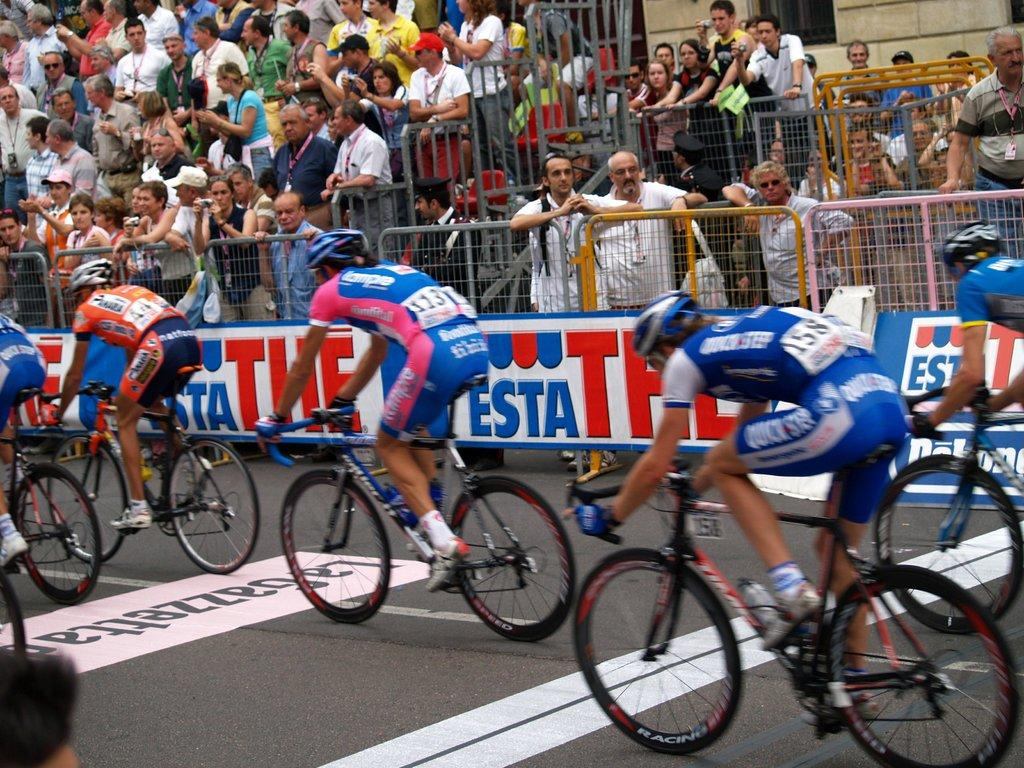<image>
Give a short and clear explanation of the subsequent image. A group of cyclists are racing down a street past banners that say The Esta. 